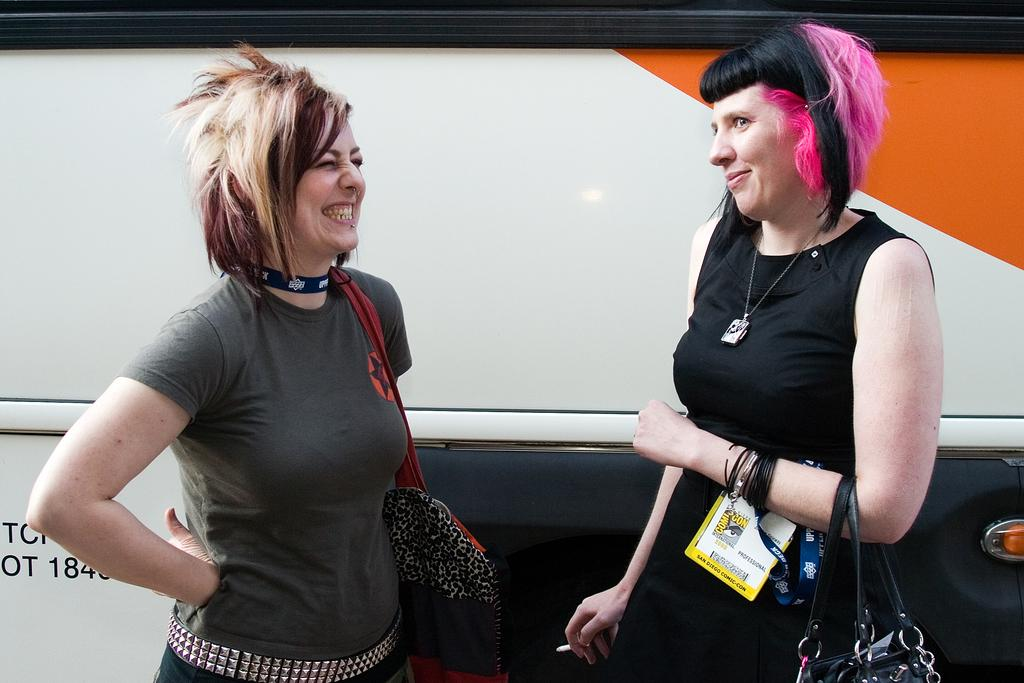How many ladies are present in the image? There are two ladies in the image. What are the ladies doing in the image? The ladies are standing beside a vehicle. Are the ladies holding anything in the image? Yes, two of the ladies are holding bags, one lady is holding a cigarette, and one lady has an access card in her hand. What type of berry is the robin eating in the image? There is no robin or berry present in the image; it features two ladies standing beside a vehicle. 